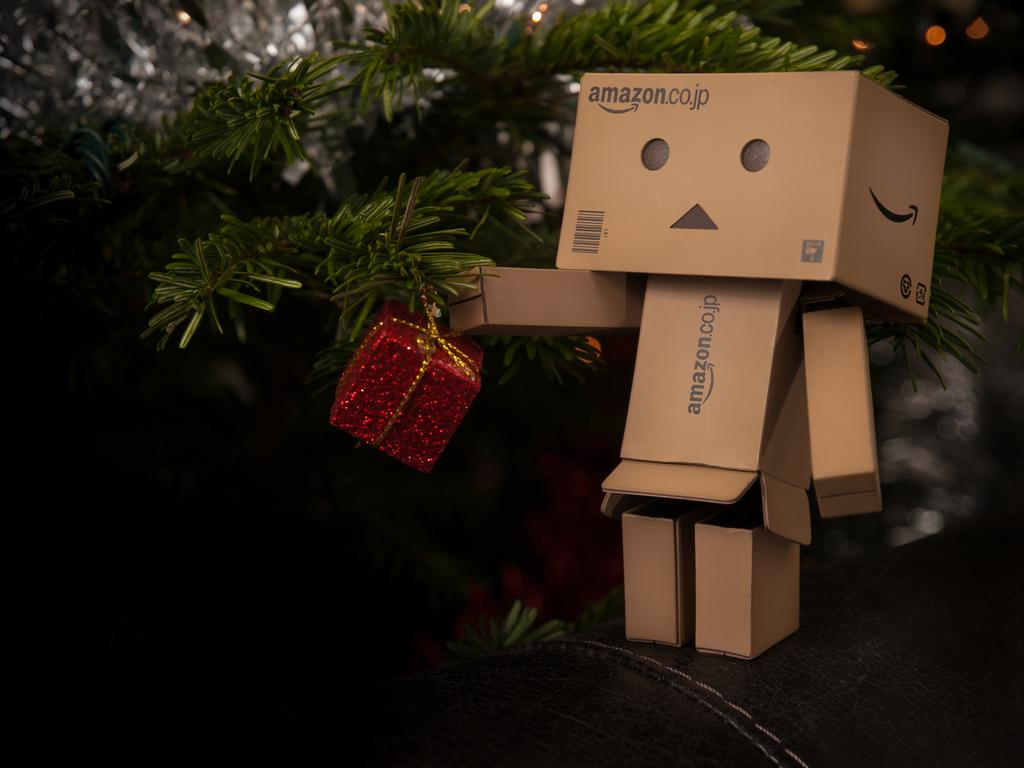What type of toy can be seen on the right side of the image? There is a cardboard toy on the right side of the image. What is located in the center of the image? There is a gift box in the center of the image. Are there any plants visible in the image? Yes, there are plants in the image. What type of shock can be seen in the image? There is no shock present in the image. Is there a lawyer visible in the image? There is no lawyer present in the image. 